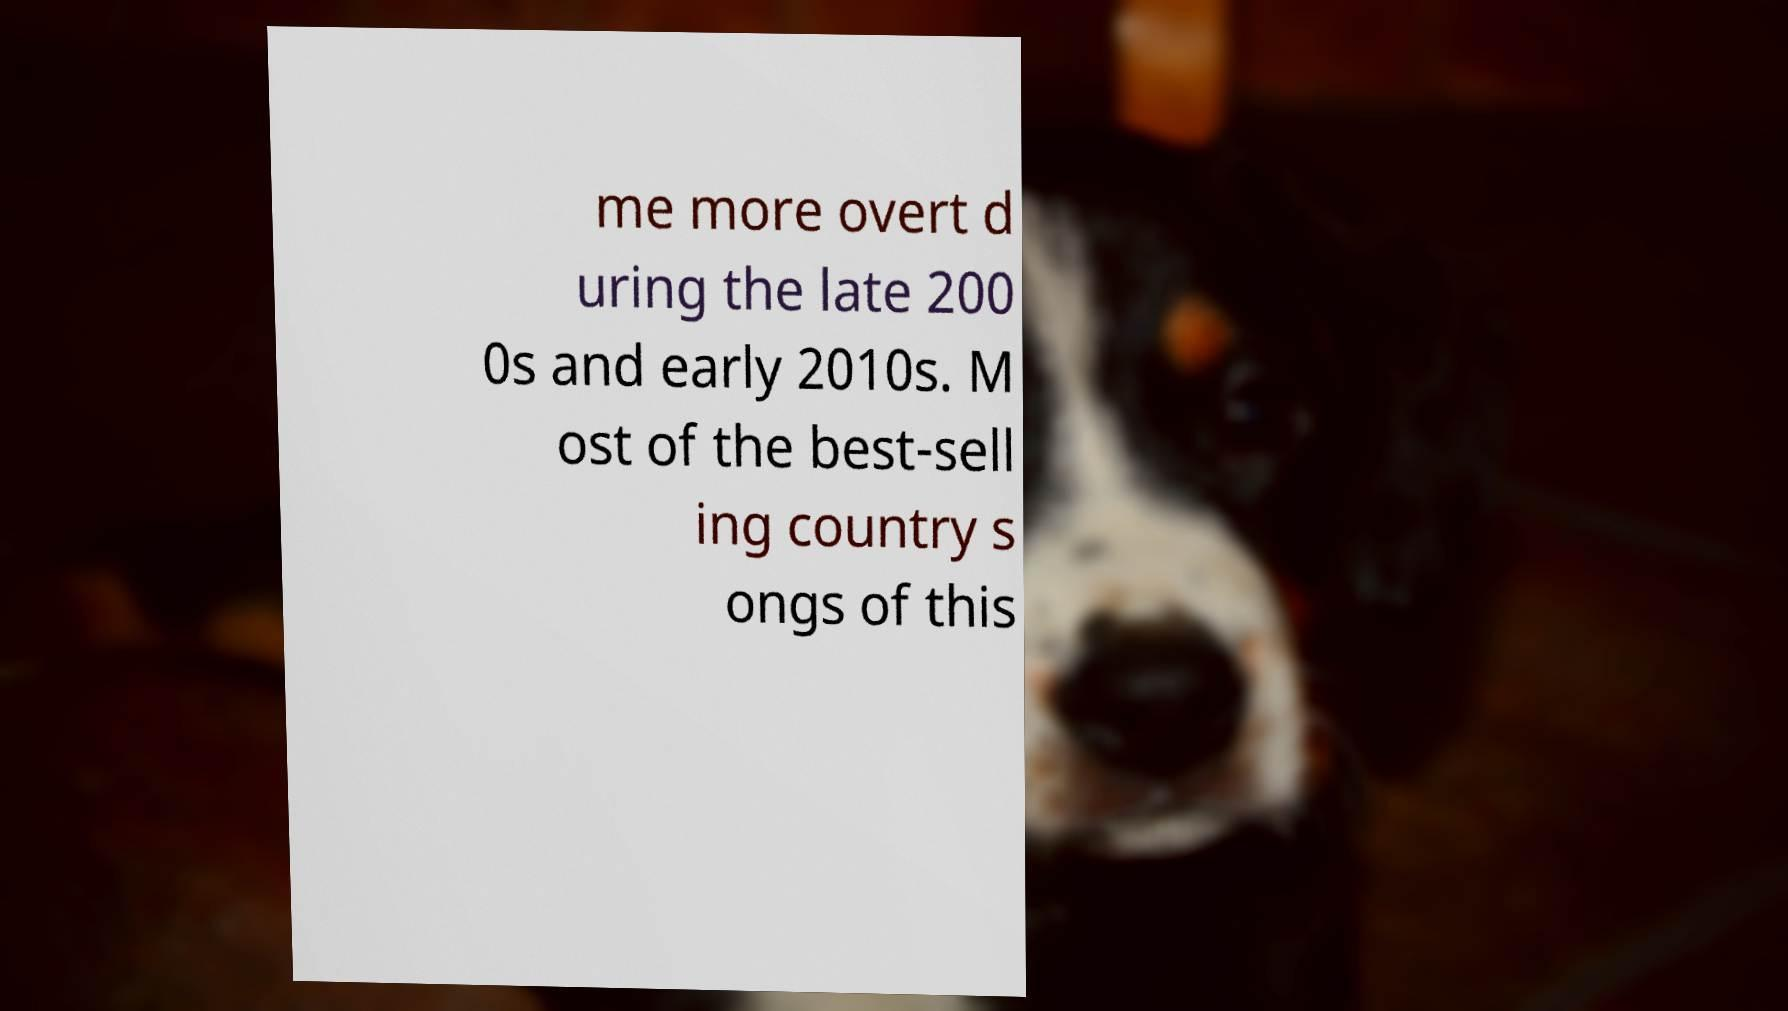For documentation purposes, I need the text within this image transcribed. Could you provide that? me more overt d uring the late 200 0s and early 2010s. M ost of the best-sell ing country s ongs of this 